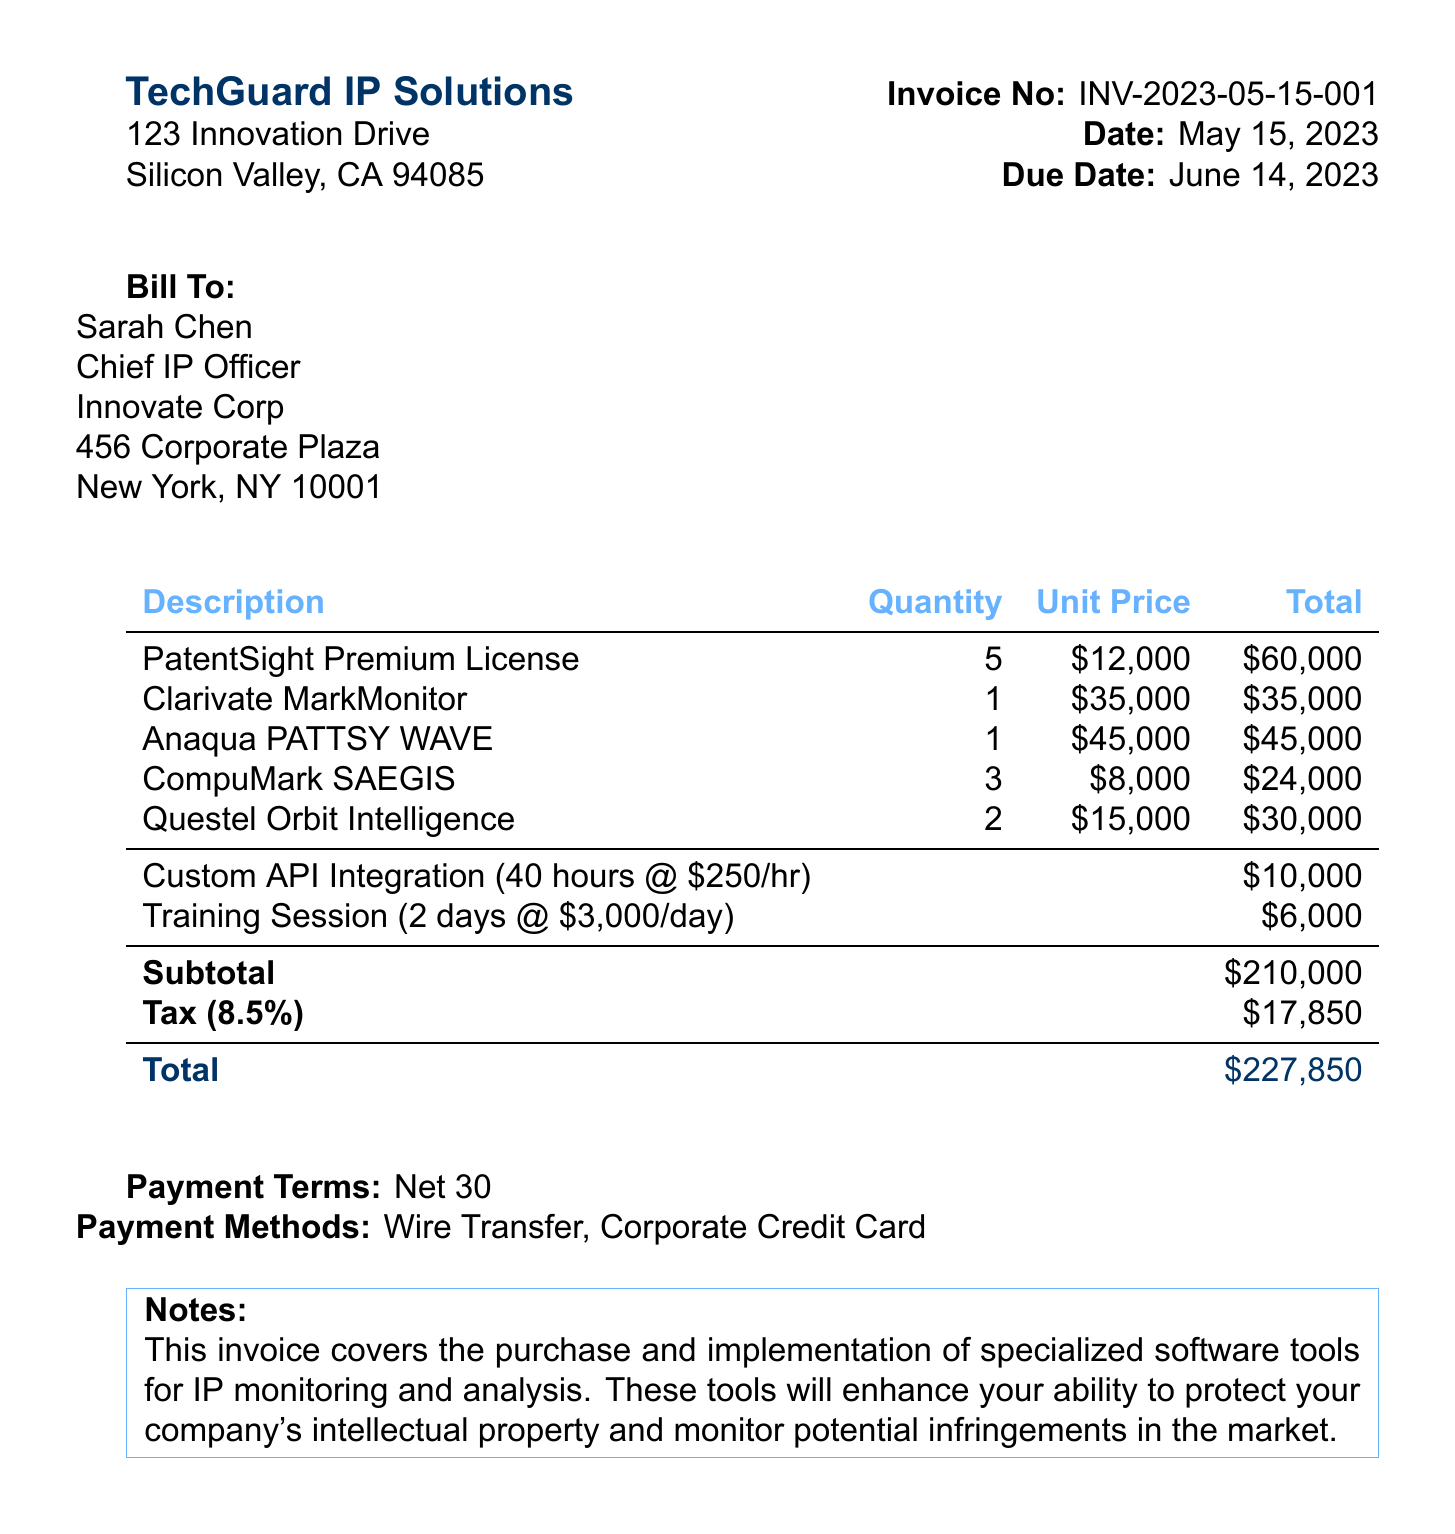what is the invoice number? The invoice number is clearly stated at the top of the document.
Answer: INV-2023-05-15-001 who is the Chief IP Officer? The person's name and title are specified in the billing section of the invoice.
Answer: Sarah Chen what is the total due? The total amount due is summarized at the end of the invoice under Totals.
Answer: $227,850 how many PatentSight Premium Licenses were purchased? The quantity is listed in the line items section.
Answer: 5 what is the tax rate applied? The tax rate is provided in the totals section.
Answer: 8.5% what service is included with the "Custom API Integration"? The description shows what the service entails.
Answer: Integration of IP monitoring tools with internal systems how many hours were allocated for the Custom API Integration? This detail is specified in the additional services section of the document.
Answer: 40 what is the payment term? The payment term details are explicitly noted in the document.
Answer: Net 30 what is the address of TechGuard IP Solutions? The company's address is mentioned in the header of the invoice.
Answer: 123 Innovation Drive, Silicon Valley, CA 94085 